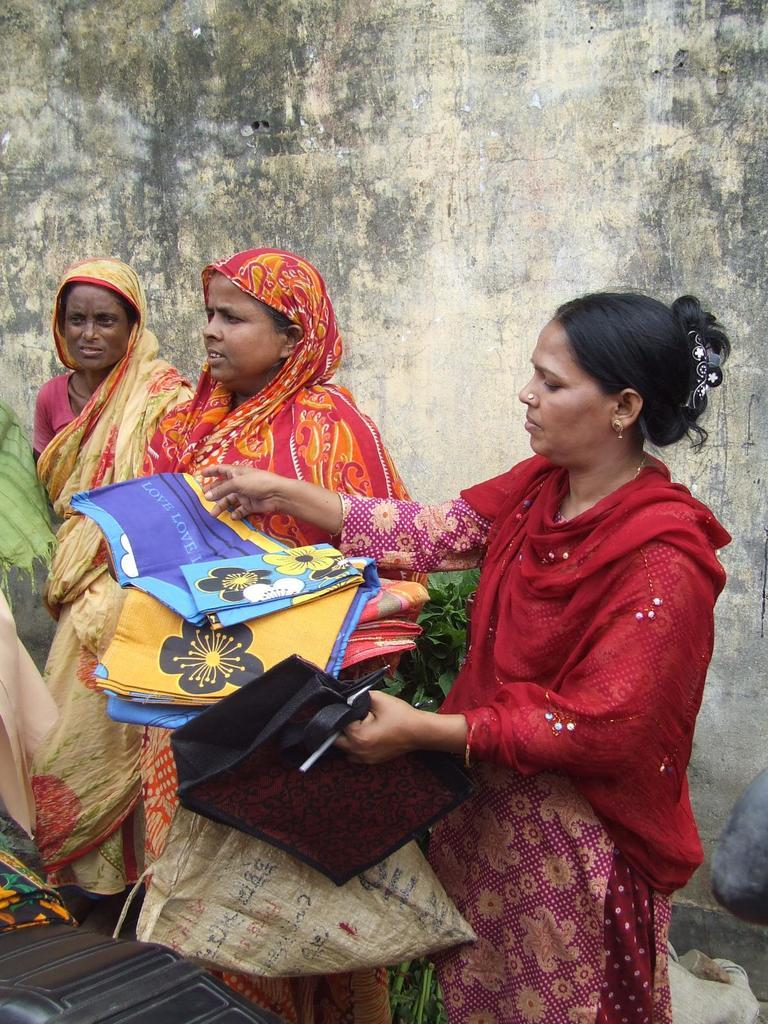How many women are in the image? There are three women in the image. Where is one of the women located in the image? One of the women is on the right side of the image. What is the woman on the right doing in the image? The woman on the right is holding things in her hands. What can be seen in the background of the image? There is a wall visible in the background of the image. What is the chance of rain in the image? There is no mention of rain or weather conditions in the image, so it's not possible to determine the chance of rain. 